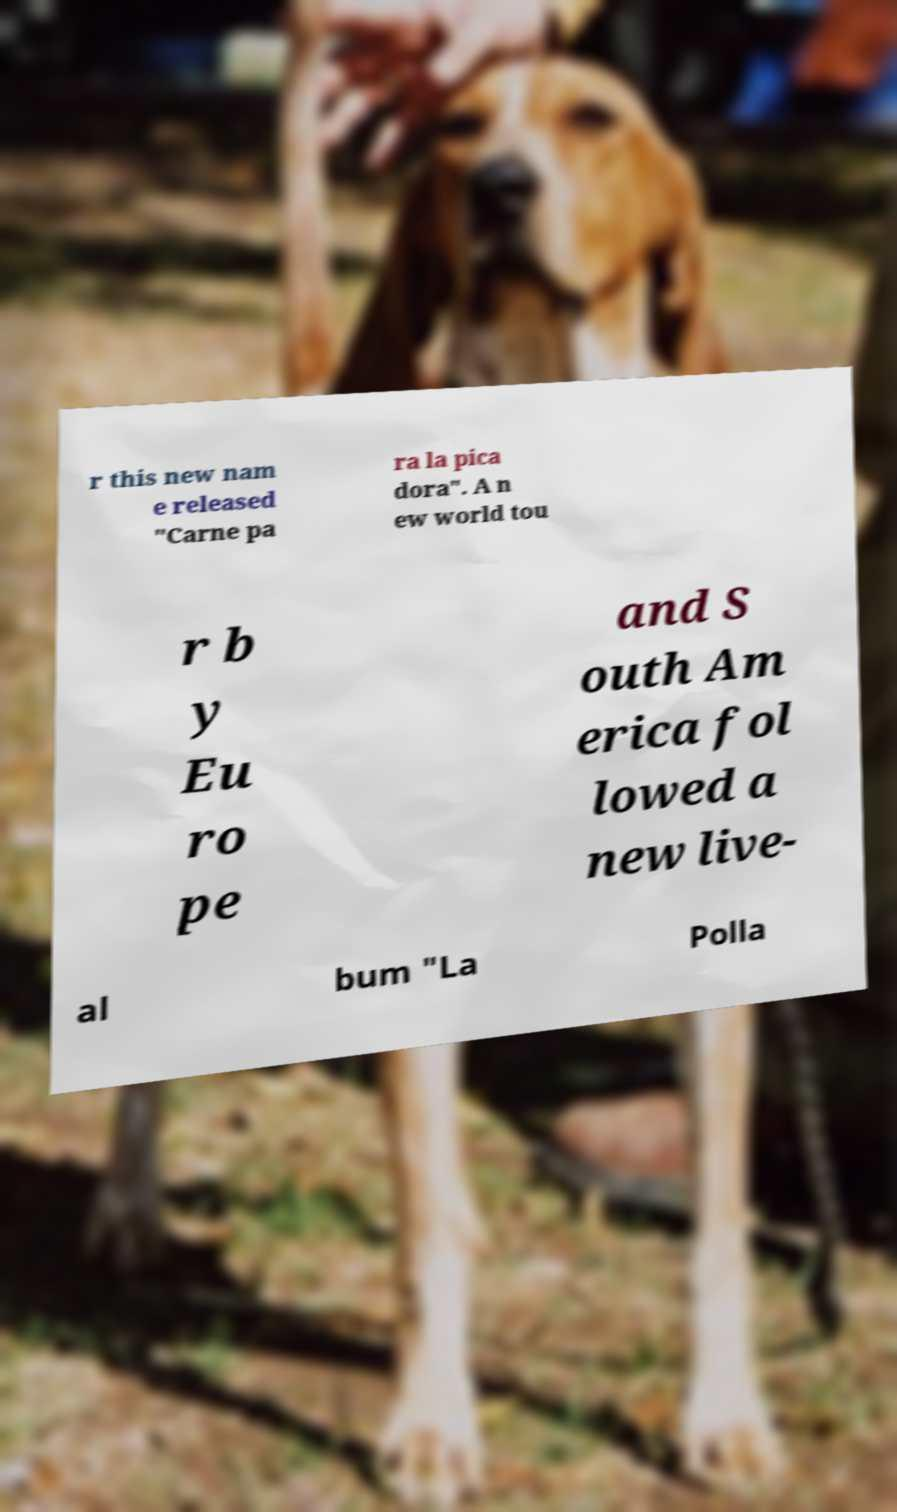Can you read and provide the text displayed in the image?This photo seems to have some interesting text. Can you extract and type it out for me? r this new nam e released "Carne pa ra la pica dora". A n ew world tou r b y Eu ro pe and S outh Am erica fol lowed a new live- al bum "La Polla 